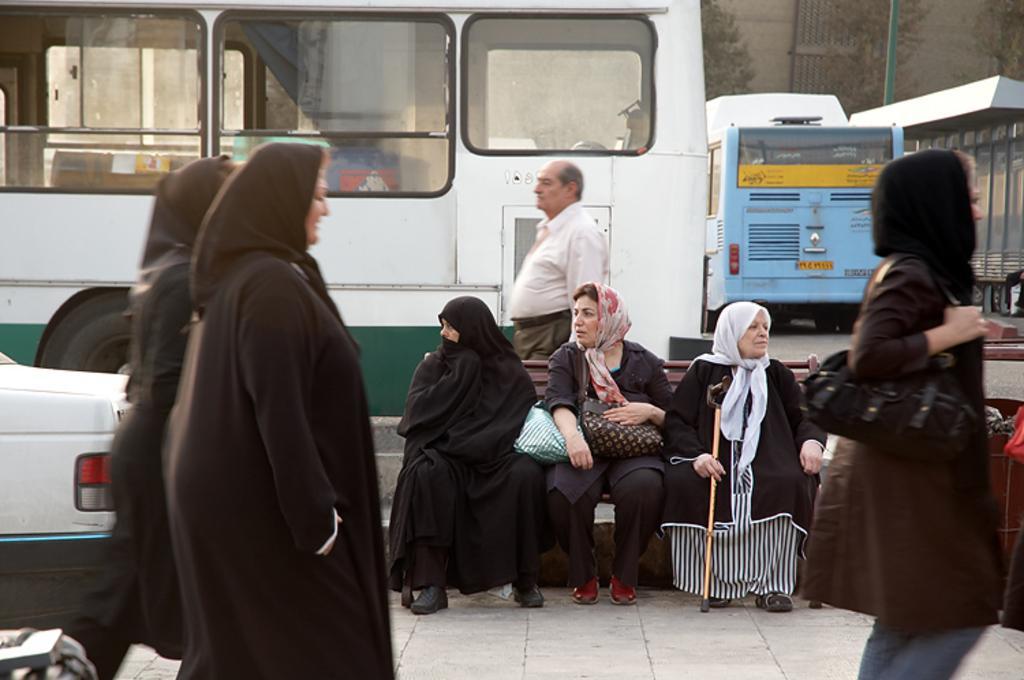In one or two sentences, can you explain what this image depicts? In this image we can see some people and among them few people sitting on the bench and there are some vehicles. We can see some trees and there is a building in the background. 